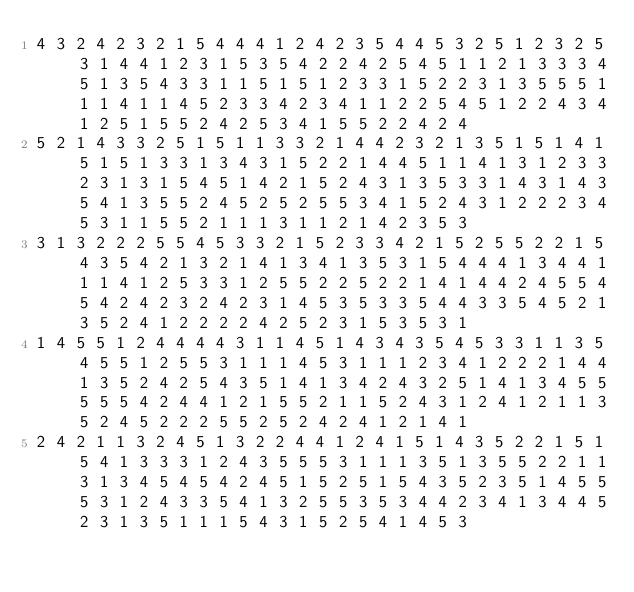Convert code to text. <code><loc_0><loc_0><loc_500><loc_500><_Matlab_>4 3 2 4 2 3 2 1 5 4 4 4 1 2 4 2 3 5 4 4 5 3 2 5 1 2 3 2 5 3 1 4 4 1 2 3 1 5 3 5 4 2 2 4 2 5 4 5 1 1 2 1 3 3 3 4 5 1 3 5 4 3 3 1 1 5 1 5 1 2 3 3 1 5 2 2 3 1 3 5 5 5 1 1 1 4 1 1 4 5 2 3 3 4 2 3 4 1 1 2 2 5 4 5 1 2 2 4 3 4 1 2 5 1 5 5 2 4 2 5 3 4 1 5 5 2 2 4 2 4
5 2 1 4 3 3 2 5 1 5 1 1 3 3 2 1 4 4 2 3 2 1 3 5 1 5 1 4 1 5 1 5 1 3 3 1 3 4 3 1 5 2 2 1 4 4 5 1 1 4 1 3 1 2 3 3 2 3 1 3 1 5 4 5 1 4 2 1 5 2 4 3 1 3 5 3 3 1 4 3 1 4 3 5 4 1 3 5 5 2 4 5 2 5 2 5 5 3 4 1 5 2 4 3 1 2 2 2 3 4 5 3 1 1 5 5 2 1 1 1 3 1 1 2 1 4 2 3 5 3
3 1 3 2 2 2 5 5 4 5 3 3 2 1 5 2 3 3 4 2 1 5 2 5 5 2 2 1 5 4 3 5 4 2 1 3 2 1 4 1 3 4 1 3 5 3 1 5 4 4 4 1 3 4 4 1 1 1 4 1 2 5 3 3 1 2 5 5 2 2 5 2 2 1 4 1 4 4 2 4 5 5 4 5 4 2 4 2 3 2 4 2 3 1 4 5 3 5 3 3 5 4 4 3 3 5 4 5 2 1 3 5 2 4 1 2 2 2 2 4 2 5 2 3 1 5 3 5 3 1
1 4 5 5 1 2 4 4 4 4 3 1 1 4 5 1 4 3 4 3 5 4 5 3 3 1 1 3 5 4 5 5 1 2 5 5 3 1 1 1 4 5 3 1 1 1 2 3 4 1 2 2 2 1 4 4 1 3 5 2 4 2 5 4 3 5 1 4 1 3 4 2 4 3 2 5 1 4 1 3 4 5 5 5 5 5 4 2 4 4 1 2 1 5 5 2 1 1 5 2 4 3 1 2 4 1 2 1 1 3 5 2 4 5 2 2 2 5 5 2 5 2 4 2 4 1 2 1 4 1
2 4 2 1 1 3 2 4 5 1 3 2 2 4 4 1 2 4 1 5 1 4 3 5 2 2 1 5 1 5 4 1 3 3 3 1 2 4 3 5 5 5 3 1 1 1 3 5 1 3 5 5 2 2 1 1 3 1 3 4 5 4 5 4 2 4 5 1 5 2 5 1 5 4 3 5 2 3 5 1 4 5 5 5 3 1 2 4 3 3 5 4 1 3 2 5 5 3 5 3 4 4 2 3 4 1 3 4 4 5 2 3 1 3 5 1 1 1 5 4 3 1 5 2 5 4 1 4 5 3</code> 